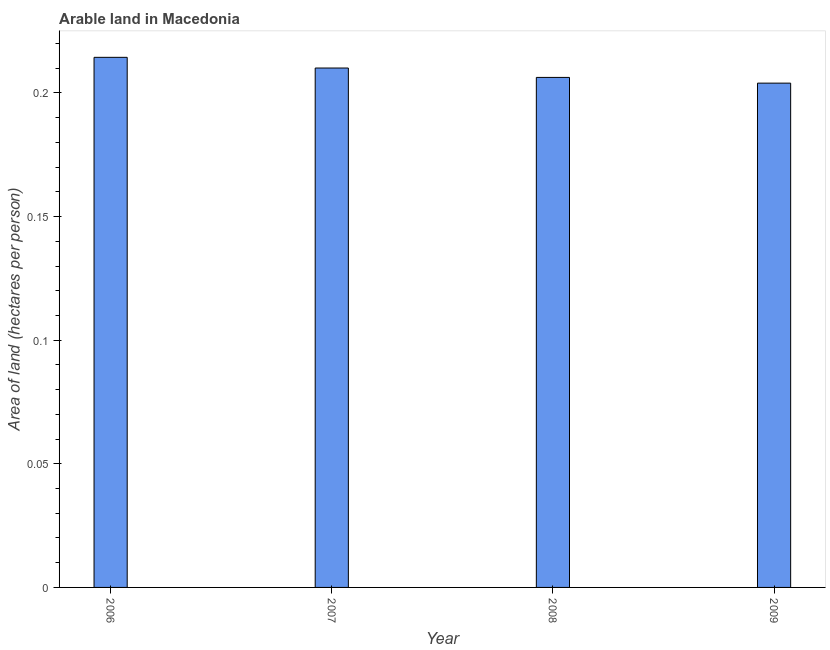Does the graph contain any zero values?
Your response must be concise. No. What is the title of the graph?
Your response must be concise. Arable land in Macedonia. What is the label or title of the X-axis?
Make the answer very short. Year. What is the label or title of the Y-axis?
Make the answer very short. Area of land (hectares per person). What is the area of arable land in 2009?
Ensure brevity in your answer.  0.2. Across all years, what is the maximum area of arable land?
Your answer should be very brief. 0.21. Across all years, what is the minimum area of arable land?
Your answer should be compact. 0.2. In which year was the area of arable land maximum?
Your answer should be very brief. 2006. In which year was the area of arable land minimum?
Give a very brief answer. 2009. What is the sum of the area of arable land?
Ensure brevity in your answer.  0.83. What is the difference between the area of arable land in 2006 and 2008?
Provide a short and direct response. 0.01. What is the average area of arable land per year?
Your answer should be compact. 0.21. What is the median area of arable land?
Your answer should be very brief. 0.21. In how many years, is the area of arable land greater than 0.04 hectares per person?
Provide a short and direct response. 4. What is the ratio of the area of arable land in 2007 to that in 2008?
Offer a very short reply. 1.02. Is the difference between the area of arable land in 2006 and 2007 greater than the difference between any two years?
Provide a succinct answer. No. What is the difference between the highest and the second highest area of arable land?
Provide a succinct answer. 0. What is the difference between the highest and the lowest area of arable land?
Provide a succinct answer. 0.01. How many bars are there?
Keep it short and to the point. 4. Are all the bars in the graph horizontal?
Give a very brief answer. No. How many years are there in the graph?
Provide a succinct answer. 4. What is the difference between two consecutive major ticks on the Y-axis?
Ensure brevity in your answer.  0.05. Are the values on the major ticks of Y-axis written in scientific E-notation?
Your answer should be compact. No. What is the Area of land (hectares per person) in 2006?
Provide a short and direct response. 0.21. What is the Area of land (hectares per person) in 2007?
Provide a short and direct response. 0.21. What is the Area of land (hectares per person) in 2008?
Offer a very short reply. 0.21. What is the Area of land (hectares per person) of 2009?
Make the answer very short. 0.2. What is the difference between the Area of land (hectares per person) in 2006 and 2007?
Provide a short and direct response. 0. What is the difference between the Area of land (hectares per person) in 2006 and 2008?
Offer a terse response. 0.01. What is the difference between the Area of land (hectares per person) in 2006 and 2009?
Make the answer very short. 0.01. What is the difference between the Area of land (hectares per person) in 2007 and 2008?
Your answer should be compact. 0. What is the difference between the Area of land (hectares per person) in 2007 and 2009?
Provide a short and direct response. 0.01. What is the difference between the Area of land (hectares per person) in 2008 and 2009?
Provide a succinct answer. 0. What is the ratio of the Area of land (hectares per person) in 2006 to that in 2008?
Your answer should be very brief. 1.04. What is the ratio of the Area of land (hectares per person) in 2006 to that in 2009?
Provide a succinct answer. 1.05. 